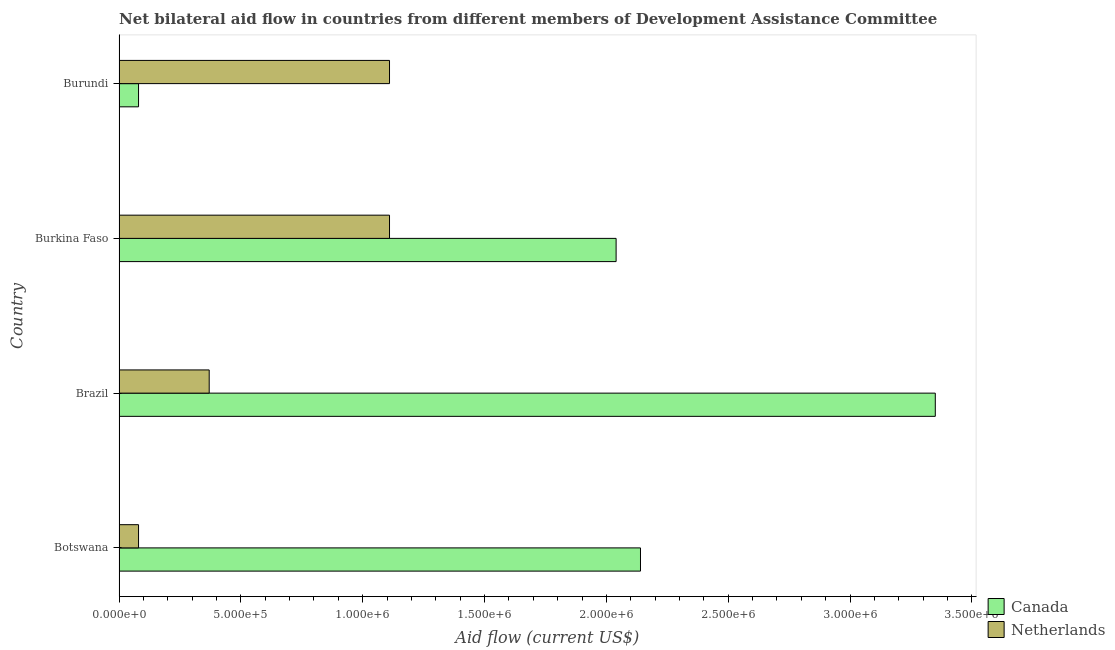How many groups of bars are there?
Make the answer very short. 4. Are the number of bars per tick equal to the number of legend labels?
Your response must be concise. Yes. Are the number of bars on each tick of the Y-axis equal?
Keep it short and to the point. Yes. How many bars are there on the 4th tick from the top?
Offer a terse response. 2. How many bars are there on the 3rd tick from the bottom?
Ensure brevity in your answer.  2. What is the label of the 3rd group of bars from the top?
Give a very brief answer. Brazil. What is the amount of aid given by canada in Brazil?
Give a very brief answer. 3.35e+06. Across all countries, what is the maximum amount of aid given by canada?
Your answer should be compact. 3.35e+06. Across all countries, what is the minimum amount of aid given by netherlands?
Offer a very short reply. 8.00e+04. In which country was the amount of aid given by netherlands maximum?
Provide a short and direct response. Burkina Faso. In which country was the amount of aid given by netherlands minimum?
Your answer should be compact. Botswana. What is the total amount of aid given by canada in the graph?
Give a very brief answer. 7.61e+06. What is the difference between the amount of aid given by canada in Burkina Faso and that in Burundi?
Your answer should be compact. 1.96e+06. What is the difference between the amount of aid given by canada in Brazil and the amount of aid given by netherlands in Burkina Faso?
Your answer should be compact. 2.24e+06. What is the average amount of aid given by canada per country?
Provide a short and direct response. 1.90e+06. What is the difference between the amount of aid given by netherlands and amount of aid given by canada in Burundi?
Provide a short and direct response. 1.03e+06. In how many countries, is the amount of aid given by netherlands greater than 3100000 US$?
Offer a very short reply. 0. What is the ratio of the amount of aid given by canada in Botswana to that in Burkina Faso?
Provide a succinct answer. 1.05. Is the amount of aid given by canada in Burkina Faso less than that in Burundi?
Ensure brevity in your answer.  No. Is the difference between the amount of aid given by netherlands in Brazil and Burkina Faso greater than the difference between the amount of aid given by canada in Brazil and Burkina Faso?
Make the answer very short. No. What is the difference between the highest and the second highest amount of aid given by canada?
Provide a succinct answer. 1.21e+06. What is the difference between the highest and the lowest amount of aid given by netherlands?
Give a very brief answer. 1.03e+06. Is the sum of the amount of aid given by canada in Botswana and Burundi greater than the maximum amount of aid given by netherlands across all countries?
Your response must be concise. Yes. What does the 1st bar from the top in Botswana represents?
Your answer should be compact. Netherlands. What does the 2nd bar from the bottom in Botswana represents?
Provide a succinct answer. Netherlands. How many countries are there in the graph?
Your answer should be very brief. 4. Does the graph contain any zero values?
Your response must be concise. No. What is the title of the graph?
Your answer should be compact. Net bilateral aid flow in countries from different members of Development Assistance Committee. What is the Aid flow (current US$) in Canada in Botswana?
Your answer should be compact. 2.14e+06. What is the Aid flow (current US$) in Canada in Brazil?
Make the answer very short. 3.35e+06. What is the Aid flow (current US$) of Netherlands in Brazil?
Your answer should be compact. 3.70e+05. What is the Aid flow (current US$) of Canada in Burkina Faso?
Give a very brief answer. 2.04e+06. What is the Aid flow (current US$) in Netherlands in Burkina Faso?
Offer a terse response. 1.11e+06. What is the Aid flow (current US$) in Canada in Burundi?
Provide a short and direct response. 8.00e+04. What is the Aid flow (current US$) in Netherlands in Burundi?
Your response must be concise. 1.11e+06. Across all countries, what is the maximum Aid flow (current US$) of Canada?
Offer a terse response. 3.35e+06. Across all countries, what is the maximum Aid flow (current US$) of Netherlands?
Keep it short and to the point. 1.11e+06. Across all countries, what is the minimum Aid flow (current US$) in Netherlands?
Provide a succinct answer. 8.00e+04. What is the total Aid flow (current US$) of Canada in the graph?
Your answer should be very brief. 7.61e+06. What is the total Aid flow (current US$) of Netherlands in the graph?
Your answer should be compact. 2.67e+06. What is the difference between the Aid flow (current US$) of Canada in Botswana and that in Brazil?
Make the answer very short. -1.21e+06. What is the difference between the Aid flow (current US$) of Netherlands in Botswana and that in Brazil?
Give a very brief answer. -2.90e+05. What is the difference between the Aid flow (current US$) in Netherlands in Botswana and that in Burkina Faso?
Ensure brevity in your answer.  -1.03e+06. What is the difference between the Aid flow (current US$) of Canada in Botswana and that in Burundi?
Provide a short and direct response. 2.06e+06. What is the difference between the Aid flow (current US$) of Netherlands in Botswana and that in Burundi?
Keep it short and to the point. -1.03e+06. What is the difference between the Aid flow (current US$) of Canada in Brazil and that in Burkina Faso?
Provide a short and direct response. 1.31e+06. What is the difference between the Aid flow (current US$) of Netherlands in Brazil and that in Burkina Faso?
Your answer should be very brief. -7.40e+05. What is the difference between the Aid flow (current US$) in Canada in Brazil and that in Burundi?
Make the answer very short. 3.27e+06. What is the difference between the Aid flow (current US$) in Netherlands in Brazil and that in Burundi?
Your answer should be compact. -7.40e+05. What is the difference between the Aid flow (current US$) of Canada in Burkina Faso and that in Burundi?
Your answer should be compact. 1.96e+06. What is the difference between the Aid flow (current US$) of Netherlands in Burkina Faso and that in Burundi?
Provide a short and direct response. 0. What is the difference between the Aid flow (current US$) of Canada in Botswana and the Aid flow (current US$) of Netherlands in Brazil?
Offer a very short reply. 1.77e+06. What is the difference between the Aid flow (current US$) of Canada in Botswana and the Aid flow (current US$) of Netherlands in Burkina Faso?
Make the answer very short. 1.03e+06. What is the difference between the Aid flow (current US$) in Canada in Botswana and the Aid flow (current US$) in Netherlands in Burundi?
Provide a succinct answer. 1.03e+06. What is the difference between the Aid flow (current US$) in Canada in Brazil and the Aid flow (current US$) in Netherlands in Burkina Faso?
Provide a succinct answer. 2.24e+06. What is the difference between the Aid flow (current US$) in Canada in Brazil and the Aid flow (current US$) in Netherlands in Burundi?
Give a very brief answer. 2.24e+06. What is the difference between the Aid flow (current US$) in Canada in Burkina Faso and the Aid flow (current US$) in Netherlands in Burundi?
Keep it short and to the point. 9.30e+05. What is the average Aid flow (current US$) of Canada per country?
Ensure brevity in your answer.  1.90e+06. What is the average Aid flow (current US$) in Netherlands per country?
Keep it short and to the point. 6.68e+05. What is the difference between the Aid flow (current US$) of Canada and Aid flow (current US$) of Netherlands in Botswana?
Ensure brevity in your answer.  2.06e+06. What is the difference between the Aid flow (current US$) in Canada and Aid flow (current US$) in Netherlands in Brazil?
Make the answer very short. 2.98e+06. What is the difference between the Aid flow (current US$) of Canada and Aid flow (current US$) of Netherlands in Burkina Faso?
Give a very brief answer. 9.30e+05. What is the difference between the Aid flow (current US$) of Canada and Aid flow (current US$) of Netherlands in Burundi?
Offer a very short reply. -1.03e+06. What is the ratio of the Aid flow (current US$) of Canada in Botswana to that in Brazil?
Provide a short and direct response. 0.64. What is the ratio of the Aid flow (current US$) of Netherlands in Botswana to that in Brazil?
Make the answer very short. 0.22. What is the ratio of the Aid flow (current US$) of Canada in Botswana to that in Burkina Faso?
Give a very brief answer. 1.05. What is the ratio of the Aid flow (current US$) in Netherlands in Botswana to that in Burkina Faso?
Your answer should be compact. 0.07. What is the ratio of the Aid flow (current US$) of Canada in Botswana to that in Burundi?
Provide a succinct answer. 26.75. What is the ratio of the Aid flow (current US$) of Netherlands in Botswana to that in Burundi?
Make the answer very short. 0.07. What is the ratio of the Aid flow (current US$) of Canada in Brazil to that in Burkina Faso?
Your answer should be compact. 1.64. What is the ratio of the Aid flow (current US$) in Netherlands in Brazil to that in Burkina Faso?
Keep it short and to the point. 0.33. What is the ratio of the Aid flow (current US$) of Canada in Brazil to that in Burundi?
Make the answer very short. 41.88. What is the ratio of the Aid flow (current US$) in Canada in Burkina Faso to that in Burundi?
Your answer should be compact. 25.5. What is the ratio of the Aid flow (current US$) of Netherlands in Burkina Faso to that in Burundi?
Offer a very short reply. 1. What is the difference between the highest and the second highest Aid flow (current US$) of Canada?
Your response must be concise. 1.21e+06. What is the difference between the highest and the second highest Aid flow (current US$) in Netherlands?
Offer a very short reply. 0. What is the difference between the highest and the lowest Aid flow (current US$) in Canada?
Offer a very short reply. 3.27e+06. What is the difference between the highest and the lowest Aid flow (current US$) in Netherlands?
Offer a terse response. 1.03e+06. 